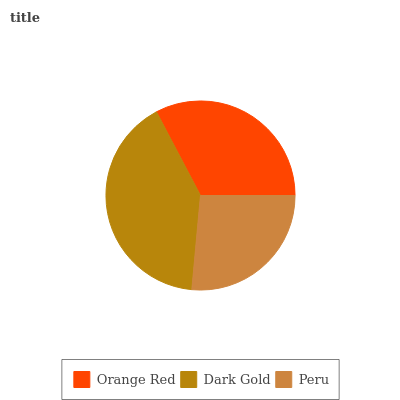Is Peru the minimum?
Answer yes or no. Yes. Is Dark Gold the maximum?
Answer yes or no. Yes. Is Dark Gold the minimum?
Answer yes or no. No. Is Peru the maximum?
Answer yes or no. No. Is Dark Gold greater than Peru?
Answer yes or no. Yes. Is Peru less than Dark Gold?
Answer yes or no. Yes. Is Peru greater than Dark Gold?
Answer yes or no. No. Is Dark Gold less than Peru?
Answer yes or no. No. Is Orange Red the high median?
Answer yes or no. Yes. Is Orange Red the low median?
Answer yes or no. Yes. Is Peru the high median?
Answer yes or no. No. Is Peru the low median?
Answer yes or no. No. 